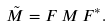Convert formula to latex. <formula><loc_0><loc_0><loc_500><loc_500>\tilde { M } = F \, M \, F ^ { * } .</formula> 